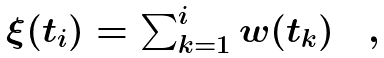<formula> <loc_0><loc_0><loc_500><loc_500>\begin{array} { c } \xi ( t _ { i } ) = \sum _ { k = 1 } ^ { i } w ( t _ { k } ) \quad , \end{array}</formula> 